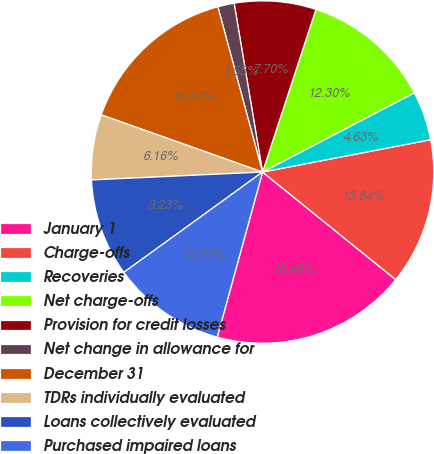Convert chart. <chart><loc_0><loc_0><loc_500><loc_500><pie_chart><fcel>January 1<fcel>Charge-offs<fcel>Recoveries<fcel>Net charge-offs<fcel>Provision for credit losses<fcel>Net change in allowance for<fcel>December 31<fcel>TDRs individually evaluated<fcel>Loans collectively evaluated<fcel>Purchased impaired loans<nl><fcel>18.45%<fcel>13.84%<fcel>4.63%<fcel>12.3%<fcel>7.7%<fcel>1.55%<fcel>15.37%<fcel>6.16%<fcel>9.23%<fcel>10.77%<nl></chart> 